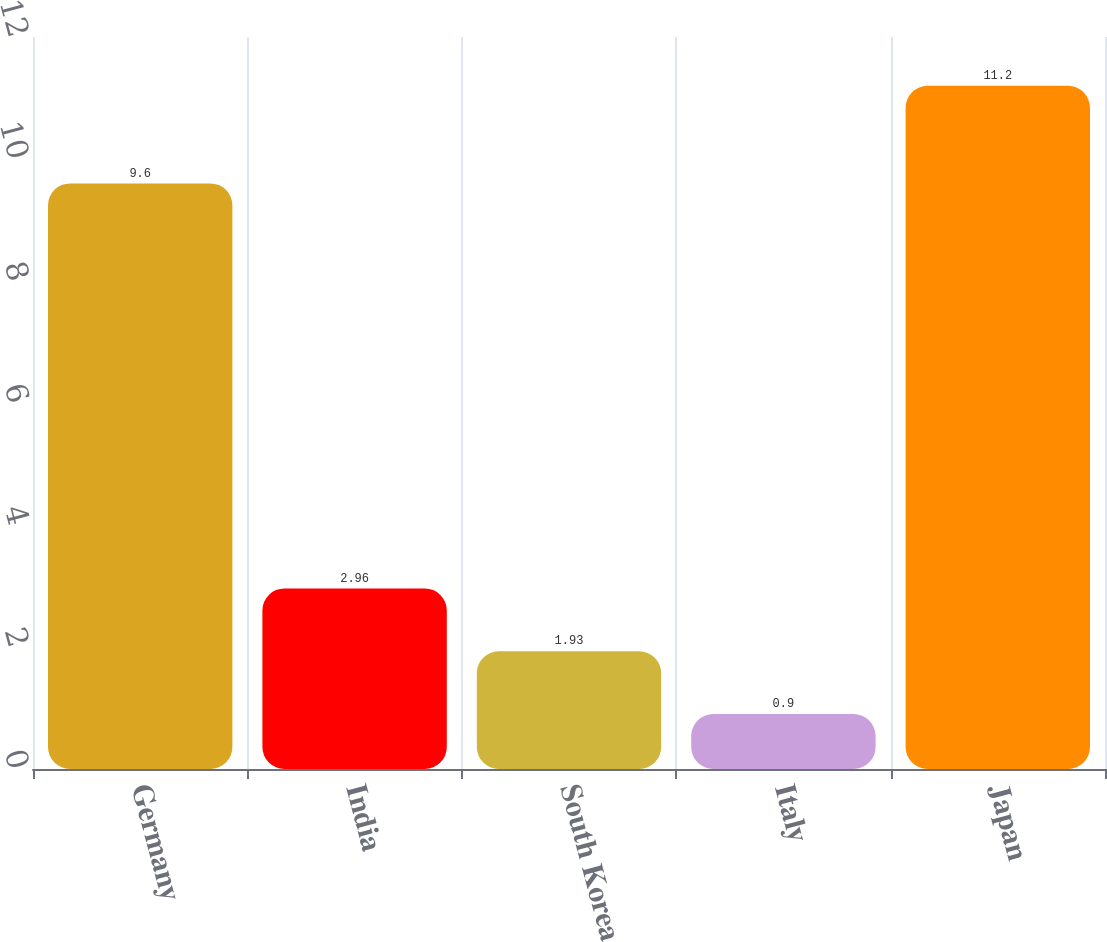Convert chart. <chart><loc_0><loc_0><loc_500><loc_500><bar_chart><fcel>Germany<fcel>India<fcel>South Korea<fcel>Italy<fcel>Japan<nl><fcel>9.6<fcel>2.96<fcel>1.93<fcel>0.9<fcel>11.2<nl></chart> 